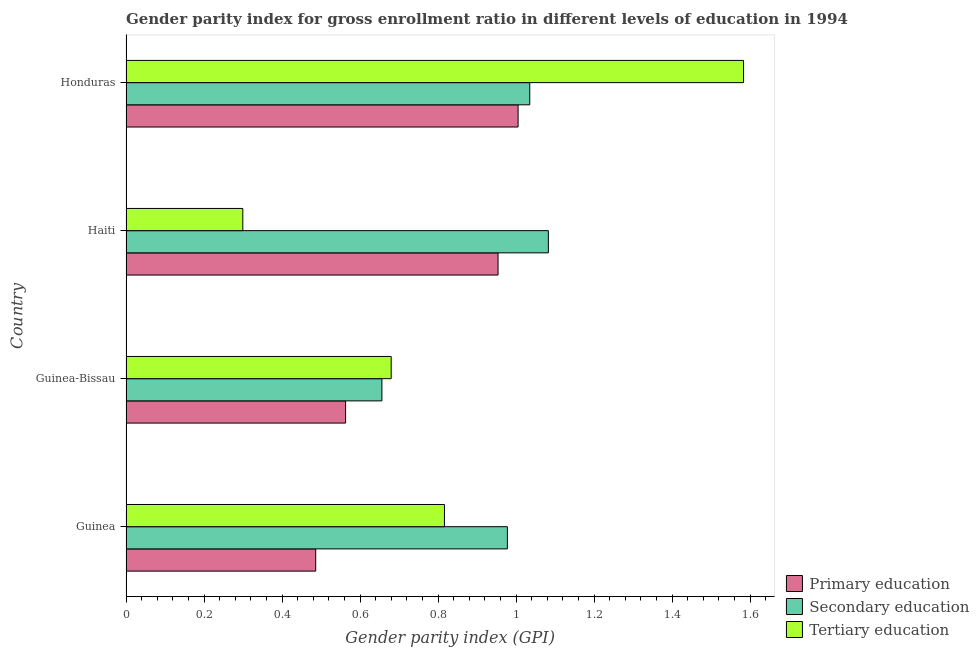How many different coloured bars are there?
Your answer should be very brief. 3. How many bars are there on the 3rd tick from the top?
Your answer should be compact. 3. What is the label of the 3rd group of bars from the top?
Keep it short and to the point. Guinea-Bissau. What is the gender parity index in secondary education in Guinea-Bissau?
Provide a short and direct response. 0.66. Across all countries, what is the maximum gender parity index in primary education?
Your answer should be compact. 1.01. Across all countries, what is the minimum gender parity index in primary education?
Provide a short and direct response. 0.49. In which country was the gender parity index in primary education maximum?
Provide a short and direct response. Honduras. In which country was the gender parity index in secondary education minimum?
Offer a very short reply. Guinea-Bissau. What is the total gender parity index in tertiary education in the graph?
Ensure brevity in your answer.  3.38. What is the difference between the gender parity index in secondary education in Guinea and that in Haiti?
Provide a succinct answer. -0.1. What is the difference between the gender parity index in tertiary education in Honduras and the gender parity index in secondary education in Haiti?
Make the answer very short. 0.5. What is the average gender parity index in primary education per country?
Your response must be concise. 0.75. What is the difference between the gender parity index in tertiary education and gender parity index in secondary education in Haiti?
Give a very brief answer. -0.78. In how many countries, is the gender parity index in secondary education greater than 1.12 ?
Ensure brevity in your answer.  0. What is the ratio of the gender parity index in tertiary education in Guinea-Bissau to that in Honduras?
Keep it short and to the point. 0.43. Is the gender parity index in tertiary education in Guinea less than that in Haiti?
Provide a short and direct response. No. Is the difference between the gender parity index in primary education in Haiti and Honduras greater than the difference between the gender parity index in secondary education in Haiti and Honduras?
Give a very brief answer. No. What is the difference between the highest and the second highest gender parity index in secondary education?
Give a very brief answer. 0.05. What is the difference between the highest and the lowest gender parity index in secondary education?
Provide a short and direct response. 0.43. In how many countries, is the gender parity index in secondary education greater than the average gender parity index in secondary education taken over all countries?
Provide a succinct answer. 3. Is the sum of the gender parity index in tertiary education in Guinea-Bissau and Honduras greater than the maximum gender parity index in secondary education across all countries?
Offer a terse response. Yes. What does the 1st bar from the top in Honduras represents?
Your answer should be compact. Tertiary education. What does the 2nd bar from the bottom in Guinea-Bissau represents?
Make the answer very short. Secondary education. Is it the case that in every country, the sum of the gender parity index in primary education and gender parity index in secondary education is greater than the gender parity index in tertiary education?
Make the answer very short. Yes. Are all the bars in the graph horizontal?
Offer a very short reply. Yes. How many countries are there in the graph?
Your answer should be very brief. 4. What is the difference between two consecutive major ticks on the X-axis?
Keep it short and to the point. 0.2. Does the graph contain grids?
Your answer should be compact. No. Where does the legend appear in the graph?
Your answer should be very brief. Bottom right. How many legend labels are there?
Provide a succinct answer. 3. What is the title of the graph?
Your response must be concise. Gender parity index for gross enrollment ratio in different levels of education in 1994. What is the label or title of the X-axis?
Keep it short and to the point. Gender parity index (GPI). What is the Gender parity index (GPI) of Primary education in Guinea?
Ensure brevity in your answer.  0.49. What is the Gender parity index (GPI) of Secondary education in Guinea?
Provide a short and direct response. 0.98. What is the Gender parity index (GPI) of Tertiary education in Guinea?
Offer a terse response. 0.82. What is the Gender parity index (GPI) in Primary education in Guinea-Bissau?
Provide a short and direct response. 0.56. What is the Gender parity index (GPI) in Secondary education in Guinea-Bissau?
Your answer should be compact. 0.66. What is the Gender parity index (GPI) of Tertiary education in Guinea-Bissau?
Give a very brief answer. 0.68. What is the Gender parity index (GPI) of Primary education in Haiti?
Your answer should be compact. 0.95. What is the Gender parity index (GPI) of Secondary education in Haiti?
Give a very brief answer. 1.08. What is the Gender parity index (GPI) of Tertiary education in Haiti?
Make the answer very short. 0.3. What is the Gender parity index (GPI) in Primary education in Honduras?
Ensure brevity in your answer.  1.01. What is the Gender parity index (GPI) of Secondary education in Honduras?
Give a very brief answer. 1.04. What is the Gender parity index (GPI) in Tertiary education in Honduras?
Your answer should be very brief. 1.58. Across all countries, what is the maximum Gender parity index (GPI) in Primary education?
Keep it short and to the point. 1.01. Across all countries, what is the maximum Gender parity index (GPI) of Secondary education?
Offer a terse response. 1.08. Across all countries, what is the maximum Gender parity index (GPI) of Tertiary education?
Provide a succinct answer. 1.58. Across all countries, what is the minimum Gender parity index (GPI) of Primary education?
Offer a terse response. 0.49. Across all countries, what is the minimum Gender parity index (GPI) in Secondary education?
Your answer should be very brief. 0.66. Across all countries, what is the minimum Gender parity index (GPI) in Tertiary education?
Give a very brief answer. 0.3. What is the total Gender parity index (GPI) of Primary education in the graph?
Keep it short and to the point. 3.01. What is the total Gender parity index (GPI) in Secondary education in the graph?
Provide a short and direct response. 3.75. What is the total Gender parity index (GPI) of Tertiary education in the graph?
Make the answer very short. 3.38. What is the difference between the Gender parity index (GPI) of Primary education in Guinea and that in Guinea-Bissau?
Your response must be concise. -0.08. What is the difference between the Gender parity index (GPI) in Secondary education in Guinea and that in Guinea-Bissau?
Offer a terse response. 0.32. What is the difference between the Gender parity index (GPI) of Tertiary education in Guinea and that in Guinea-Bissau?
Make the answer very short. 0.14. What is the difference between the Gender parity index (GPI) of Primary education in Guinea and that in Haiti?
Offer a very short reply. -0.47. What is the difference between the Gender parity index (GPI) of Secondary education in Guinea and that in Haiti?
Your answer should be very brief. -0.1. What is the difference between the Gender parity index (GPI) of Tertiary education in Guinea and that in Haiti?
Ensure brevity in your answer.  0.52. What is the difference between the Gender parity index (GPI) of Primary education in Guinea and that in Honduras?
Provide a succinct answer. -0.52. What is the difference between the Gender parity index (GPI) in Secondary education in Guinea and that in Honduras?
Ensure brevity in your answer.  -0.06. What is the difference between the Gender parity index (GPI) in Tertiary education in Guinea and that in Honduras?
Keep it short and to the point. -0.77. What is the difference between the Gender parity index (GPI) of Primary education in Guinea-Bissau and that in Haiti?
Your response must be concise. -0.39. What is the difference between the Gender parity index (GPI) of Secondary education in Guinea-Bissau and that in Haiti?
Ensure brevity in your answer.  -0.43. What is the difference between the Gender parity index (GPI) in Tertiary education in Guinea-Bissau and that in Haiti?
Keep it short and to the point. 0.38. What is the difference between the Gender parity index (GPI) in Primary education in Guinea-Bissau and that in Honduras?
Provide a short and direct response. -0.44. What is the difference between the Gender parity index (GPI) in Secondary education in Guinea-Bissau and that in Honduras?
Your answer should be compact. -0.38. What is the difference between the Gender parity index (GPI) in Tertiary education in Guinea-Bissau and that in Honduras?
Your answer should be very brief. -0.9. What is the difference between the Gender parity index (GPI) of Primary education in Haiti and that in Honduras?
Offer a terse response. -0.05. What is the difference between the Gender parity index (GPI) of Secondary education in Haiti and that in Honduras?
Ensure brevity in your answer.  0.05. What is the difference between the Gender parity index (GPI) of Tertiary education in Haiti and that in Honduras?
Offer a terse response. -1.28. What is the difference between the Gender parity index (GPI) of Primary education in Guinea and the Gender parity index (GPI) of Secondary education in Guinea-Bissau?
Offer a terse response. -0.17. What is the difference between the Gender parity index (GPI) of Primary education in Guinea and the Gender parity index (GPI) of Tertiary education in Guinea-Bissau?
Give a very brief answer. -0.19. What is the difference between the Gender parity index (GPI) in Secondary education in Guinea and the Gender parity index (GPI) in Tertiary education in Guinea-Bissau?
Offer a very short reply. 0.3. What is the difference between the Gender parity index (GPI) in Primary education in Guinea and the Gender parity index (GPI) in Secondary education in Haiti?
Your response must be concise. -0.6. What is the difference between the Gender parity index (GPI) of Primary education in Guinea and the Gender parity index (GPI) of Tertiary education in Haiti?
Offer a very short reply. 0.19. What is the difference between the Gender parity index (GPI) of Secondary education in Guinea and the Gender parity index (GPI) of Tertiary education in Haiti?
Offer a very short reply. 0.68. What is the difference between the Gender parity index (GPI) in Primary education in Guinea and the Gender parity index (GPI) in Secondary education in Honduras?
Offer a very short reply. -0.55. What is the difference between the Gender parity index (GPI) of Primary education in Guinea and the Gender parity index (GPI) of Tertiary education in Honduras?
Your response must be concise. -1.1. What is the difference between the Gender parity index (GPI) of Secondary education in Guinea and the Gender parity index (GPI) of Tertiary education in Honduras?
Your answer should be very brief. -0.61. What is the difference between the Gender parity index (GPI) in Primary education in Guinea-Bissau and the Gender parity index (GPI) in Secondary education in Haiti?
Keep it short and to the point. -0.52. What is the difference between the Gender parity index (GPI) of Primary education in Guinea-Bissau and the Gender parity index (GPI) of Tertiary education in Haiti?
Make the answer very short. 0.26. What is the difference between the Gender parity index (GPI) of Secondary education in Guinea-Bissau and the Gender parity index (GPI) of Tertiary education in Haiti?
Make the answer very short. 0.36. What is the difference between the Gender parity index (GPI) in Primary education in Guinea-Bissau and the Gender parity index (GPI) in Secondary education in Honduras?
Provide a succinct answer. -0.47. What is the difference between the Gender parity index (GPI) of Primary education in Guinea-Bissau and the Gender parity index (GPI) of Tertiary education in Honduras?
Offer a terse response. -1.02. What is the difference between the Gender parity index (GPI) of Secondary education in Guinea-Bissau and the Gender parity index (GPI) of Tertiary education in Honduras?
Your answer should be compact. -0.93. What is the difference between the Gender parity index (GPI) in Primary education in Haiti and the Gender parity index (GPI) in Secondary education in Honduras?
Keep it short and to the point. -0.08. What is the difference between the Gender parity index (GPI) of Primary education in Haiti and the Gender parity index (GPI) of Tertiary education in Honduras?
Your answer should be compact. -0.63. What is the difference between the Gender parity index (GPI) of Secondary education in Haiti and the Gender parity index (GPI) of Tertiary education in Honduras?
Keep it short and to the point. -0.5. What is the average Gender parity index (GPI) of Primary education per country?
Your answer should be very brief. 0.75. What is the average Gender parity index (GPI) in Secondary education per country?
Your answer should be compact. 0.94. What is the average Gender parity index (GPI) of Tertiary education per country?
Ensure brevity in your answer.  0.84. What is the difference between the Gender parity index (GPI) of Primary education and Gender parity index (GPI) of Secondary education in Guinea?
Provide a succinct answer. -0.49. What is the difference between the Gender parity index (GPI) in Primary education and Gender parity index (GPI) in Tertiary education in Guinea?
Ensure brevity in your answer.  -0.33. What is the difference between the Gender parity index (GPI) of Secondary education and Gender parity index (GPI) of Tertiary education in Guinea?
Your answer should be compact. 0.16. What is the difference between the Gender parity index (GPI) of Primary education and Gender parity index (GPI) of Secondary education in Guinea-Bissau?
Offer a terse response. -0.09. What is the difference between the Gender parity index (GPI) of Primary education and Gender parity index (GPI) of Tertiary education in Guinea-Bissau?
Keep it short and to the point. -0.12. What is the difference between the Gender parity index (GPI) of Secondary education and Gender parity index (GPI) of Tertiary education in Guinea-Bissau?
Offer a terse response. -0.02. What is the difference between the Gender parity index (GPI) in Primary education and Gender parity index (GPI) in Secondary education in Haiti?
Offer a terse response. -0.13. What is the difference between the Gender parity index (GPI) in Primary education and Gender parity index (GPI) in Tertiary education in Haiti?
Provide a succinct answer. 0.65. What is the difference between the Gender parity index (GPI) in Secondary education and Gender parity index (GPI) in Tertiary education in Haiti?
Provide a short and direct response. 0.78. What is the difference between the Gender parity index (GPI) of Primary education and Gender parity index (GPI) of Secondary education in Honduras?
Ensure brevity in your answer.  -0.03. What is the difference between the Gender parity index (GPI) of Primary education and Gender parity index (GPI) of Tertiary education in Honduras?
Your response must be concise. -0.58. What is the difference between the Gender parity index (GPI) of Secondary education and Gender parity index (GPI) of Tertiary education in Honduras?
Make the answer very short. -0.55. What is the ratio of the Gender parity index (GPI) in Primary education in Guinea to that in Guinea-Bissau?
Provide a short and direct response. 0.86. What is the ratio of the Gender parity index (GPI) of Secondary education in Guinea to that in Guinea-Bissau?
Your answer should be very brief. 1.49. What is the ratio of the Gender parity index (GPI) in Tertiary education in Guinea to that in Guinea-Bissau?
Ensure brevity in your answer.  1.2. What is the ratio of the Gender parity index (GPI) in Primary education in Guinea to that in Haiti?
Provide a short and direct response. 0.51. What is the ratio of the Gender parity index (GPI) in Secondary education in Guinea to that in Haiti?
Offer a terse response. 0.9. What is the ratio of the Gender parity index (GPI) in Tertiary education in Guinea to that in Haiti?
Your answer should be compact. 2.73. What is the ratio of the Gender parity index (GPI) in Primary education in Guinea to that in Honduras?
Offer a terse response. 0.48. What is the ratio of the Gender parity index (GPI) in Secondary education in Guinea to that in Honduras?
Offer a terse response. 0.94. What is the ratio of the Gender parity index (GPI) of Tertiary education in Guinea to that in Honduras?
Ensure brevity in your answer.  0.52. What is the ratio of the Gender parity index (GPI) of Primary education in Guinea-Bissau to that in Haiti?
Provide a short and direct response. 0.59. What is the ratio of the Gender parity index (GPI) in Secondary education in Guinea-Bissau to that in Haiti?
Your answer should be very brief. 0.61. What is the ratio of the Gender parity index (GPI) in Tertiary education in Guinea-Bissau to that in Haiti?
Provide a short and direct response. 2.27. What is the ratio of the Gender parity index (GPI) of Primary education in Guinea-Bissau to that in Honduras?
Ensure brevity in your answer.  0.56. What is the ratio of the Gender parity index (GPI) of Secondary education in Guinea-Bissau to that in Honduras?
Provide a succinct answer. 0.63. What is the ratio of the Gender parity index (GPI) of Tertiary education in Guinea-Bissau to that in Honduras?
Make the answer very short. 0.43. What is the ratio of the Gender parity index (GPI) of Primary education in Haiti to that in Honduras?
Offer a terse response. 0.95. What is the ratio of the Gender parity index (GPI) in Secondary education in Haiti to that in Honduras?
Give a very brief answer. 1.05. What is the ratio of the Gender parity index (GPI) of Tertiary education in Haiti to that in Honduras?
Keep it short and to the point. 0.19. What is the difference between the highest and the second highest Gender parity index (GPI) of Primary education?
Offer a very short reply. 0.05. What is the difference between the highest and the second highest Gender parity index (GPI) in Secondary education?
Give a very brief answer. 0.05. What is the difference between the highest and the second highest Gender parity index (GPI) of Tertiary education?
Your answer should be very brief. 0.77. What is the difference between the highest and the lowest Gender parity index (GPI) of Primary education?
Your answer should be compact. 0.52. What is the difference between the highest and the lowest Gender parity index (GPI) in Secondary education?
Provide a succinct answer. 0.43. What is the difference between the highest and the lowest Gender parity index (GPI) in Tertiary education?
Provide a short and direct response. 1.28. 